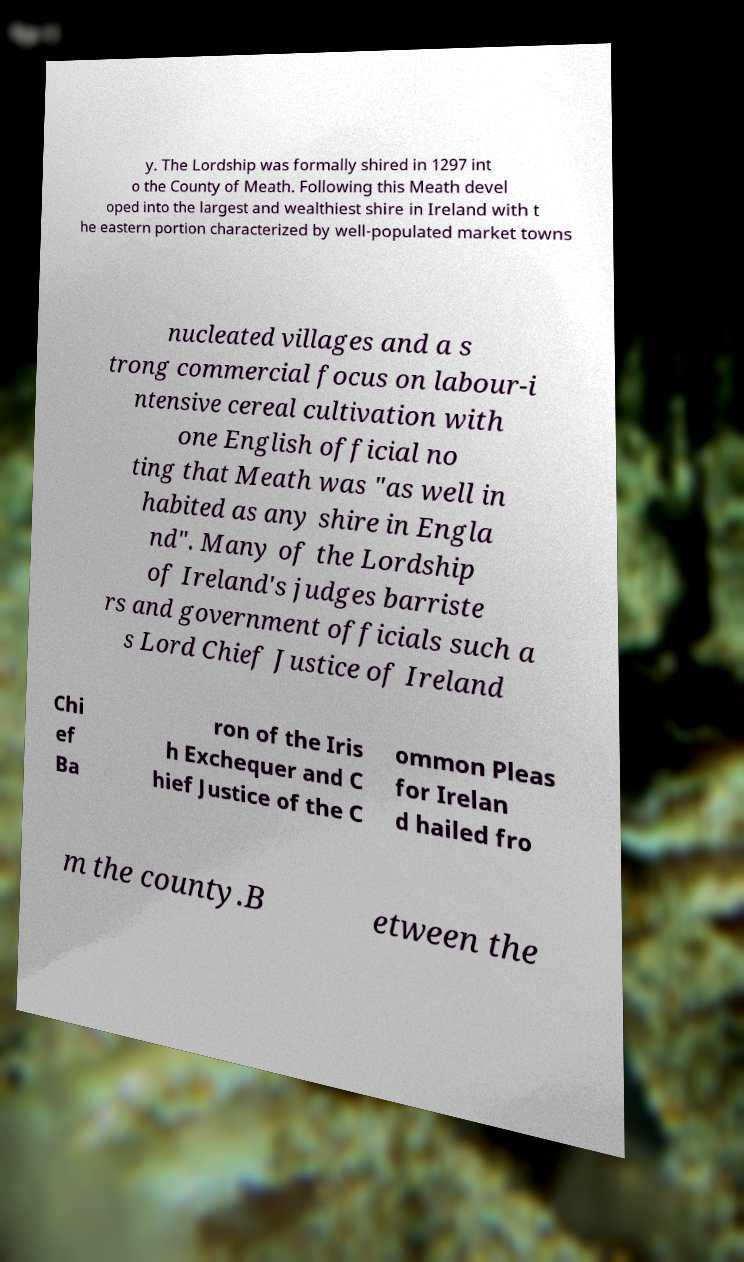Could you assist in decoding the text presented in this image and type it out clearly? y. The Lordship was formally shired in 1297 int o the County of Meath. Following this Meath devel oped into the largest and wealthiest shire in Ireland with t he eastern portion characterized by well-populated market towns nucleated villages and a s trong commercial focus on labour-i ntensive cereal cultivation with one English official no ting that Meath was "as well in habited as any shire in Engla nd". Many of the Lordship of Ireland's judges barriste rs and government officials such a s Lord Chief Justice of Ireland Chi ef Ba ron of the Iris h Exchequer and C hief Justice of the C ommon Pleas for Irelan d hailed fro m the county.B etween the 